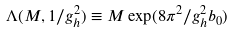<formula> <loc_0><loc_0><loc_500><loc_500>\Lambda ( M , 1 / g _ { h } ^ { 2 } ) \equiv M \exp ( 8 \pi ^ { 2 } / g _ { h } ^ { 2 } b _ { 0 } )</formula> 